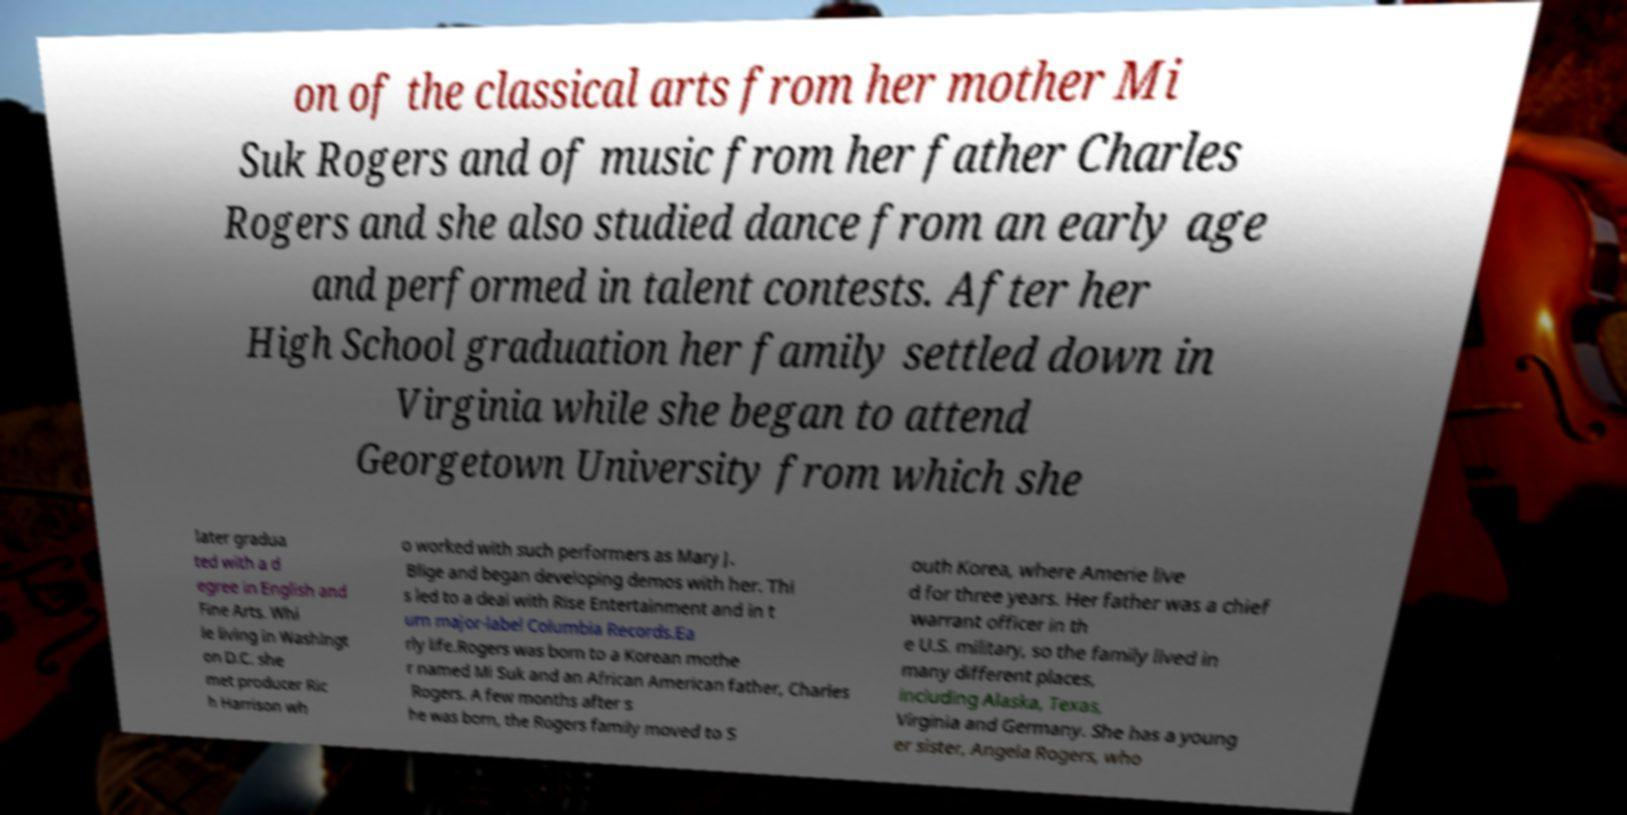Please identify and transcribe the text found in this image. on of the classical arts from her mother Mi Suk Rogers and of music from her father Charles Rogers and she also studied dance from an early age and performed in talent contests. After her High School graduation her family settled down in Virginia while she began to attend Georgetown University from which she later gradua ted with a d egree in English and Fine Arts. Whi le living in Washingt on D.C. she met producer Ric h Harrison wh o worked with such performers as Mary J. Blige and began developing demos with her. Thi s led to a deal with Rise Entertainment and in t urn major-label Columbia Records.Ea rly life.Rogers was born to a Korean mothe r named Mi Suk and an African American father, Charles Rogers. A few months after s he was born, the Rogers family moved to S outh Korea, where Amerie live d for three years. Her father was a chief warrant officer in th e U.S. military, so the family lived in many different places, including Alaska, Texas, Virginia and Germany. She has a young er sister, Angela Rogers, who 